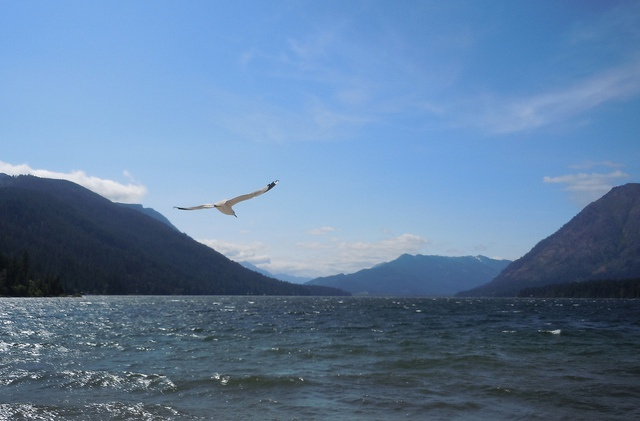Describe the objects in this image and their specific colors. I can see a bird in lightblue, darkgray, gray, and lightgray tones in this image. 